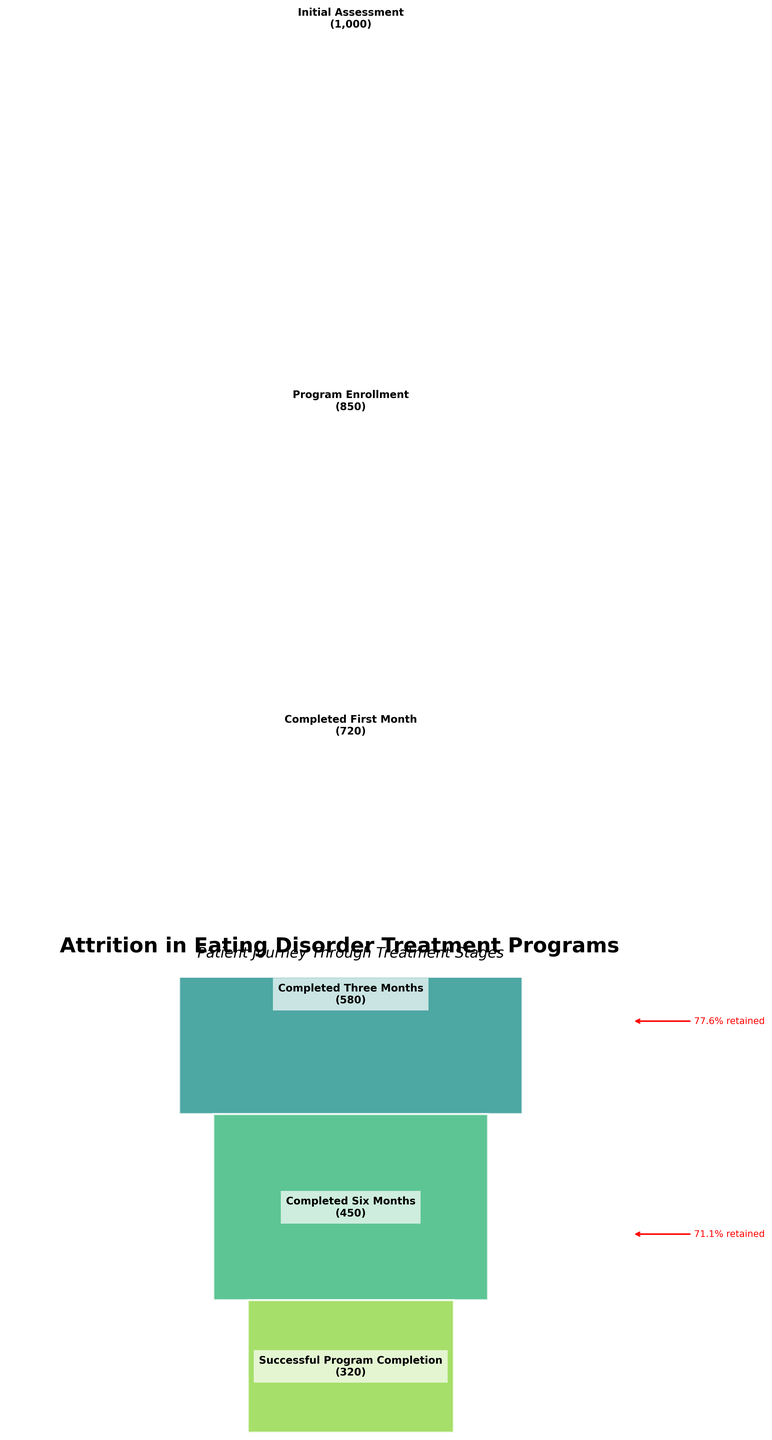What's the total number of patients who successfully completed the program? To find the total number of patients who successfully completed the program, look at the stage "Successful Program Completion" and its corresponding patient count.
Answer: 320 What percentage of patients dropped out after the first month? Calculate the difference between "Program Enrollment" and "Completed First Month," then divide by "Program Enrollment" and multiply by 100 to get the percentage. (850 - 720) / 850 * 100 = 15.29%
Answer: 15.29% How many stages are there in the treatment program? Count the stages listed from "Initial Assessment" to "Successful Program Completion."
Answer: 6 Which stage has the highest attrition rate? To find the stage with the highest attrition, look for the largest drop between consecutive stages. The largest drop is between "Completed Six Months" (450) and "Successful Program Completion" (320).
Answer: Between Completed Six Months and Successful Program Completion What is the retention rate from Initial Assessment to Successful Program Completion? Calculate the retention rate by dividing the number of patients in "Successful Program Completion" by the number of patients in "Initial Assessment" and then multiplying by 100. (320 / 1000) * 100 = 32%
Answer: 32% What is the difference in patient numbers between Completed Three Months and Completed Six Months? Subtract the number of patients at "Completed Six Months" from the number of patients at "Completed Three Months." 580 - 450 = 130
Answer: 130 How does the number of patients who completed six months compare to those who completed three months? Compare the patient numbers at "Completed Three Months" (580) to those at "Completed Six Months" (450). 450 is less than 580.
Answer: 450 is less than 580 What is the proportion of patients retained after three months compared to the initial assessment? Calculate the retention rate by dividing the number of patients in "Completed Three Months" by the number of patients in "Initial Assessment" and then multiply by 100. (580 / 1000) * 100 = 58%
Answer: 58% Explain the trend observed through the stages of the treatment program. As patients progress from "Initial Assessment" to "Successful Program Completion," the number of patients decreases at each stage. This indicates a general attrition trend where fewer patients continue at each subsequent stage of the treatment.
Answer: Decreasing attrition trend What is the overall attrition rate by the end of the program? Calculate the attrition rate by subtracting the retention rate from 100%. We already found the retention rate to be 32%, so 100% - 32% = 68%.
Answer: 68% 